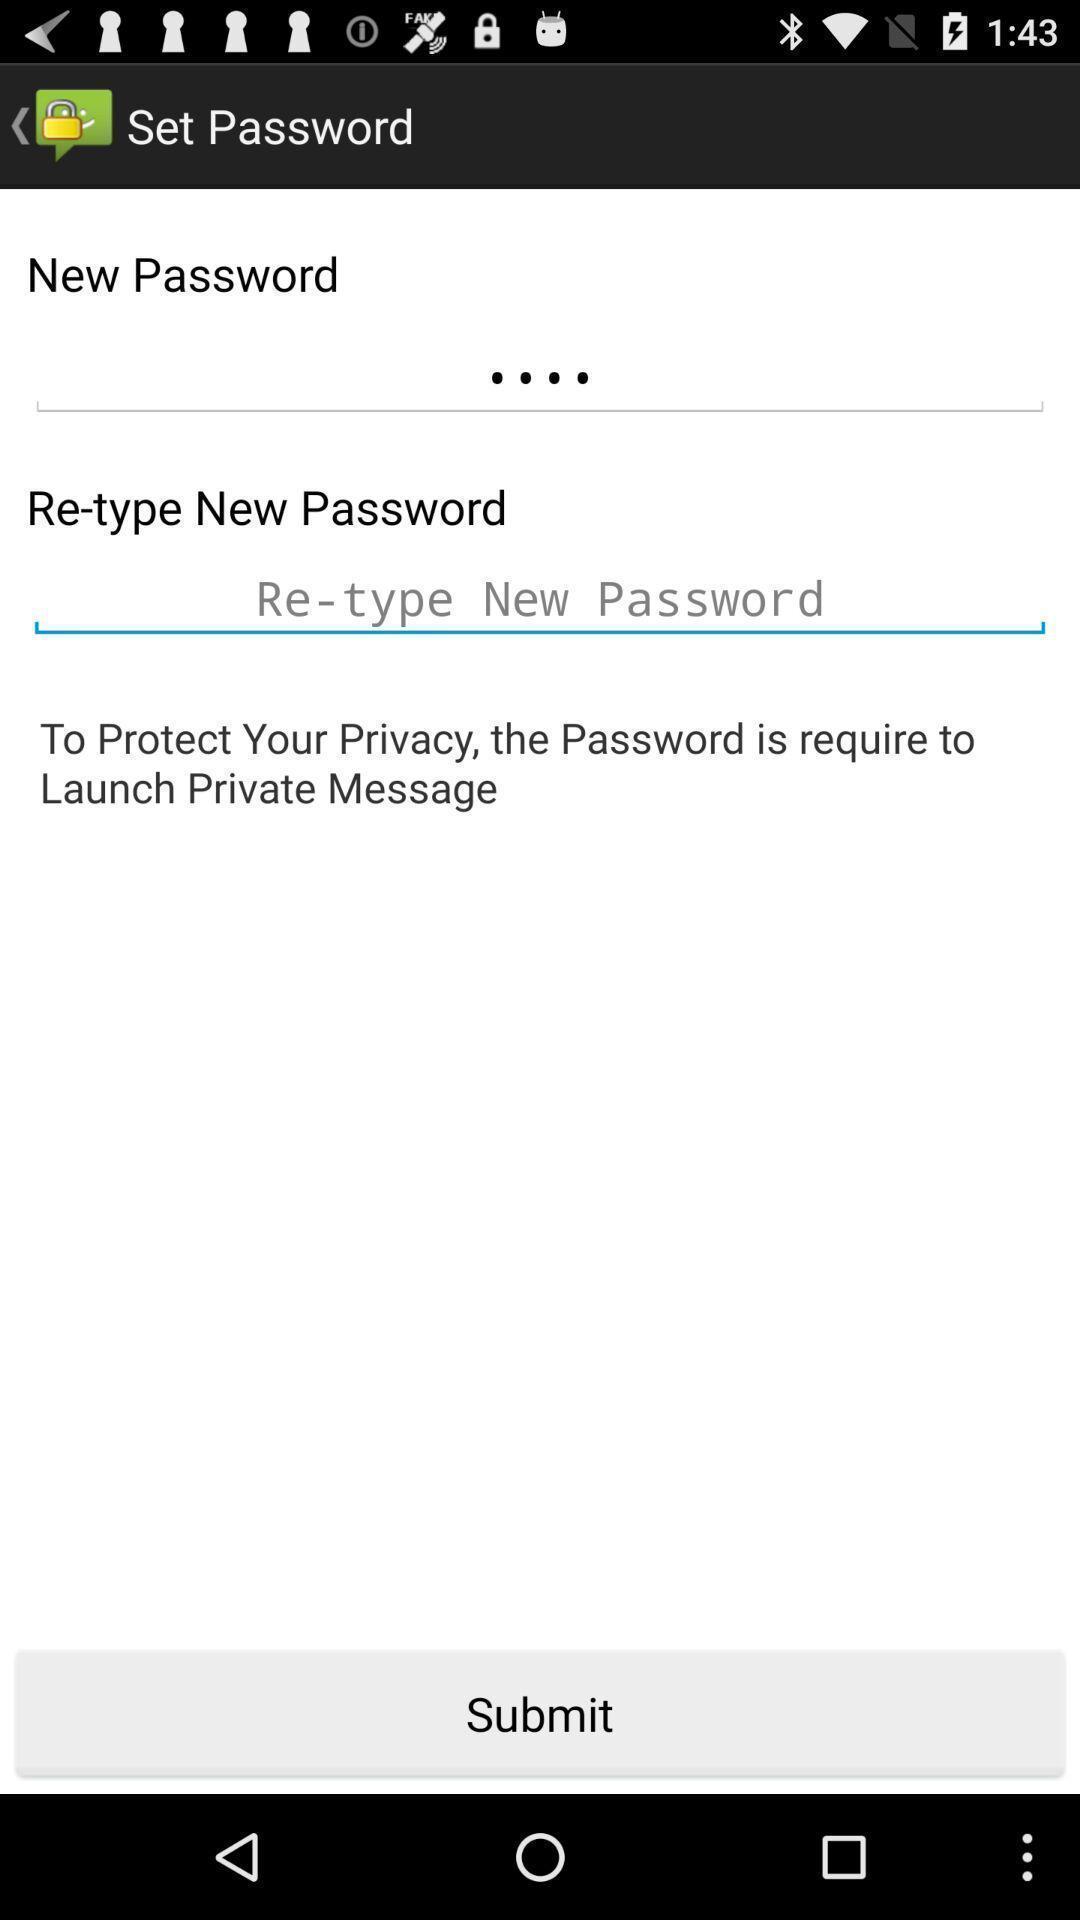Give me a narrative description of this picture. Submit page. 